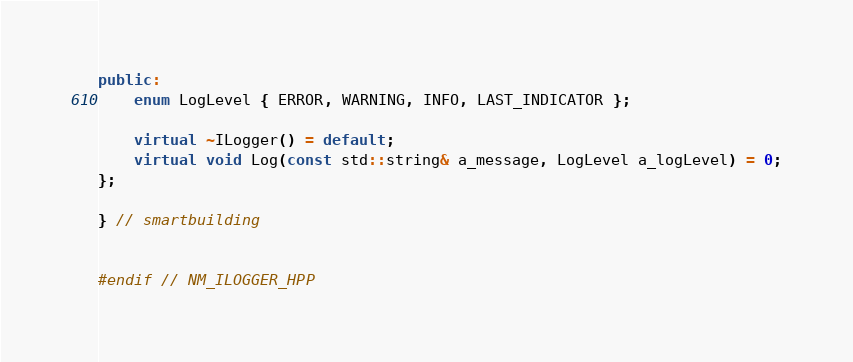Convert code to text. <code><loc_0><loc_0><loc_500><loc_500><_C++_>public:
    enum LogLevel { ERROR, WARNING, INFO, LAST_INDICATOR };

    virtual ~ILogger() = default;
    virtual void Log(const std::string& a_message, LogLevel a_logLevel) = 0;
};

} // smartbuilding


#endif // NM_ILOGGER_HPP
</code> 